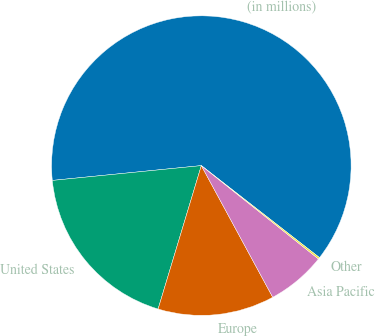Convert chart to OTSL. <chart><loc_0><loc_0><loc_500><loc_500><pie_chart><fcel>(in millions)<fcel>United States<fcel>Europe<fcel>Asia Pacific<fcel>Other<nl><fcel>62.11%<fcel>18.76%<fcel>12.57%<fcel>6.38%<fcel>0.18%<nl></chart> 